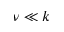<formula> <loc_0><loc_0><loc_500><loc_500>\nu \ll k</formula> 